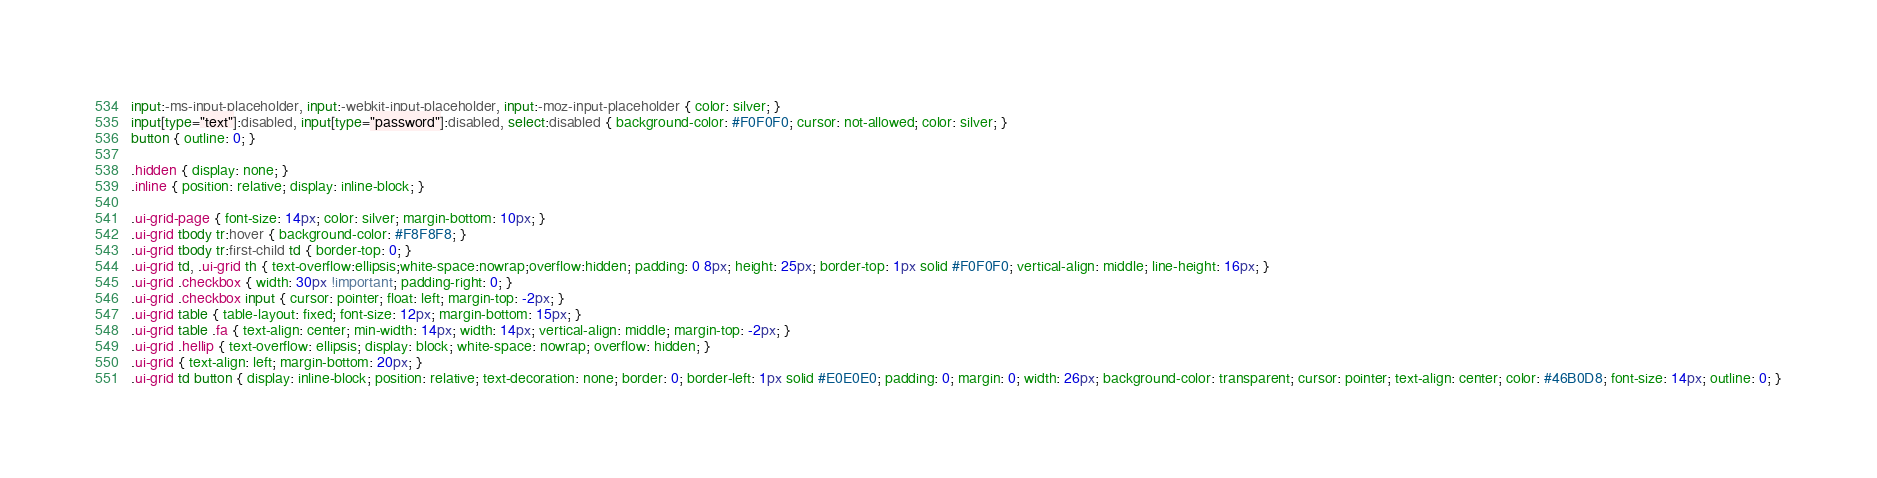Convert code to text. <code><loc_0><loc_0><loc_500><loc_500><_CSS_>input:-ms-input-placeholder, input:-webkit-input-placeholder, input:-moz-input-placeholder { color: silver; }
input[type="text"]:disabled, input[type="password"]:disabled, select:disabled { background-color: #F0F0F0; cursor: not-allowed; color: silver; }
button { outline: 0; }

.hidden { display: none; }
.inline { position: relative; display: inline-block; }

.ui-grid-page { font-size: 14px; color: silver; margin-bottom: 10px; }
.ui-grid tbody tr:hover { background-color: #F8F8F8; }
.ui-grid tbody tr:first-child td { border-top: 0; }
.ui-grid td, .ui-grid th { text-overflow:ellipsis;white-space:nowrap;overflow:hidden; padding: 0 8px; height: 25px; border-top: 1px solid #F0F0F0; vertical-align: middle; line-height: 16px; }
.ui-grid .checkbox { width: 30px !important; padding-right: 0; }
.ui-grid .checkbox input { cursor: pointer; float: left; margin-top: -2px; }
.ui-grid table { table-layout: fixed; font-size: 12px; margin-bottom: 15px; }
.ui-grid table .fa { text-align: center; min-width: 14px; width: 14px; vertical-align: middle; margin-top: -2px; }
.ui-grid .hellip { text-overflow: ellipsis; display: block; white-space: nowrap; overflow: hidden; }
.ui-grid { text-align: left; margin-bottom: 20px; }
.ui-grid td button { display: inline-block; position: relative; text-decoration: none; border: 0; border-left: 1px solid #E0E0E0; padding: 0; margin: 0; width: 26px; background-color: transparent; cursor: pointer; text-align: center; color: #46B0D8; font-size: 14px; outline: 0; }</code> 